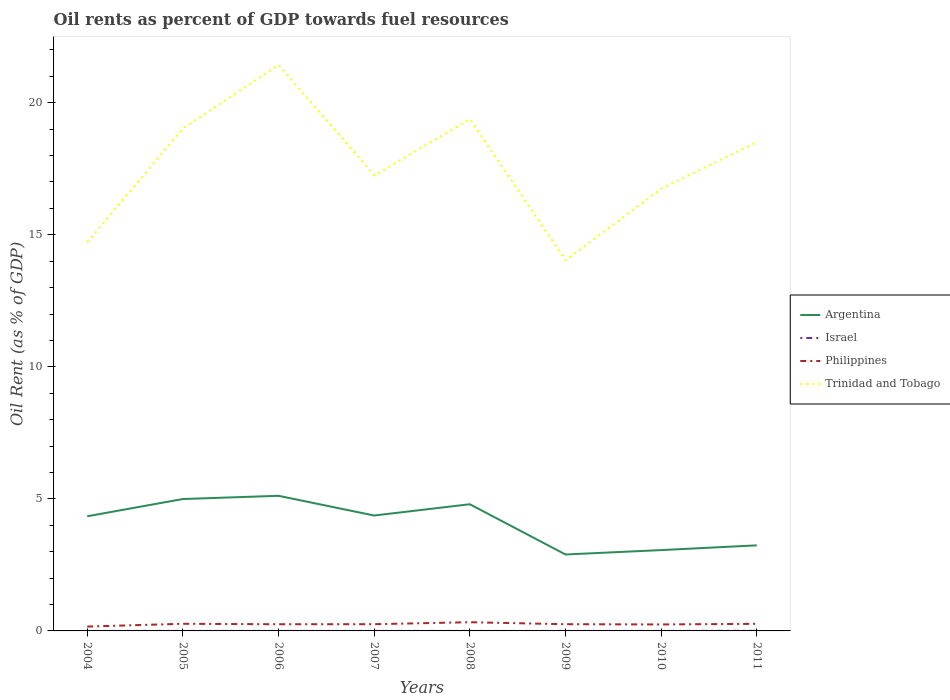How many different coloured lines are there?
Offer a terse response. 4. Across all years, what is the maximum oil rent in Philippines?
Offer a very short reply. 0.16. What is the total oil rent in Argentina in the graph?
Give a very brief answer. 1.31. What is the difference between the highest and the second highest oil rent in Philippines?
Your response must be concise. 0.17. What is the difference between the highest and the lowest oil rent in Israel?
Offer a very short reply. 1. How many lines are there?
Your answer should be very brief. 4. How many years are there in the graph?
Your answer should be compact. 8. What is the difference between two consecutive major ticks on the Y-axis?
Offer a very short reply. 5. Does the graph contain any zero values?
Give a very brief answer. No. What is the title of the graph?
Offer a terse response. Oil rents as percent of GDP towards fuel resources. Does "French Polynesia" appear as one of the legend labels in the graph?
Give a very brief answer. No. What is the label or title of the X-axis?
Your answer should be very brief. Years. What is the label or title of the Y-axis?
Make the answer very short. Oil Rent (as % of GDP). What is the Oil Rent (as % of GDP) of Argentina in 2004?
Your answer should be very brief. 4.34. What is the Oil Rent (as % of GDP) in Israel in 2004?
Keep it short and to the point. 0. What is the Oil Rent (as % of GDP) in Philippines in 2004?
Ensure brevity in your answer.  0.16. What is the Oil Rent (as % of GDP) of Trinidad and Tobago in 2004?
Provide a succinct answer. 14.72. What is the Oil Rent (as % of GDP) of Argentina in 2005?
Make the answer very short. 4.99. What is the Oil Rent (as % of GDP) in Israel in 2005?
Your answer should be very brief. 0. What is the Oil Rent (as % of GDP) of Philippines in 2005?
Ensure brevity in your answer.  0.27. What is the Oil Rent (as % of GDP) of Trinidad and Tobago in 2005?
Make the answer very short. 19.03. What is the Oil Rent (as % of GDP) of Argentina in 2006?
Give a very brief answer. 5.12. What is the Oil Rent (as % of GDP) of Israel in 2006?
Ensure brevity in your answer.  0. What is the Oil Rent (as % of GDP) in Philippines in 2006?
Your response must be concise. 0.25. What is the Oil Rent (as % of GDP) of Trinidad and Tobago in 2006?
Keep it short and to the point. 21.43. What is the Oil Rent (as % of GDP) in Argentina in 2007?
Offer a terse response. 4.37. What is the Oil Rent (as % of GDP) in Israel in 2007?
Your answer should be compact. 0. What is the Oil Rent (as % of GDP) of Philippines in 2007?
Provide a succinct answer. 0.25. What is the Oil Rent (as % of GDP) of Trinidad and Tobago in 2007?
Offer a very short reply. 17.25. What is the Oil Rent (as % of GDP) of Argentina in 2008?
Offer a very short reply. 4.8. What is the Oil Rent (as % of GDP) of Israel in 2008?
Your response must be concise. 0. What is the Oil Rent (as % of GDP) of Philippines in 2008?
Give a very brief answer. 0.33. What is the Oil Rent (as % of GDP) of Trinidad and Tobago in 2008?
Your answer should be very brief. 19.38. What is the Oil Rent (as % of GDP) in Argentina in 2009?
Your answer should be very brief. 2.89. What is the Oil Rent (as % of GDP) of Israel in 2009?
Your answer should be very brief. 0. What is the Oil Rent (as % of GDP) in Philippines in 2009?
Ensure brevity in your answer.  0.25. What is the Oil Rent (as % of GDP) of Trinidad and Tobago in 2009?
Your answer should be very brief. 14.03. What is the Oil Rent (as % of GDP) in Argentina in 2010?
Offer a terse response. 3.06. What is the Oil Rent (as % of GDP) of Israel in 2010?
Your answer should be compact. 0. What is the Oil Rent (as % of GDP) in Philippines in 2010?
Offer a terse response. 0.25. What is the Oil Rent (as % of GDP) in Trinidad and Tobago in 2010?
Provide a short and direct response. 16.75. What is the Oil Rent (as % of GDP) of Argentina in 2011?
Offer a terse response. 3.24. What is the Oil Rent (as % of GDP) of Israel in 2011?
Provide a succinct answer. 0. What is the Oil Rent (as % of GDP) of Philippines in 2011?
Ensure brevity in your answer.  0.27. What is the Oil Rent (as % of GDP) of Trinidad and Tobago in 2011?
Your answer should be compact. 18.51. Across all years, what is the maximum Oil Rent (as % of GDP) of Argentina?
Provide a short and direct response. 5.12. Across all years, what is the maximum Oil Rent (as % of GDP) in Israel?
Your answer should be compact. 0. Across all years, what is the maximum Oil Rent (as % of GDP) in Philippines?
Your response must be concise. 0.33. Across all years, what is the maximum Oil Rent (as % of GDP) in Trinidad and Tobago?
Give a very brief answer. 21.43. Across all years, what is the minimum Oil Rent (as % of GDP) in Argentina?
Make the answer very short. 2.89. Across all years, what is the minimum Oil Rent (as % of GDP) in Israel?
Provide a succinct answer. 0. Across all years, what is the minimum Oil Rent (as % of GDP) in Philippines?
Offer a terse response. 0.16. Across all years, what is the minimum Oil Rent (as % of GDP) in Trinidad and Tobago?
Your answer should be very brief. 14.03. What is the total Oil Rent (as % of GDP) in Argentina in the graph?
Make the answer very short. 32.81. What is the total Oil Rent (as % of GDP) of Israel in the graph?
Offer a very short reply. 0.01. What is the total Oil Rent (as % of GDP) in Philippines in the graph?
Your answer should be very brief. 2.04. What is the total Oil Rent (as % of GDP) in Trinidad and Tobago in the graph?
Your answer should be very brief. 141.1. What is the difference between the Oil Rent (as % of GDP) of Argentina in 2004 and that in 2005?
Your answer should be very brief. -0.65. What is the difference between the Oil Rent (as % of GDP) of Israel in 2004 and that in 2005?
Provide a short and direct response. -0. What is the difference between the Oil Rent (as % of GDP) of Philippines in 2004 and that in 2005?
Offer a terse response. -0.11. What is the difference between the Oil Rent (as % of GDP) in Trinidad and Tobago in 2004 and that in 2005?
Keep it short and to the point. -4.31. What is the difference between the Oil Rent (as % of GDP) in Argentina in 2004 and that in 2006?
Give a very brief answer. -0.78. What is the difference between the Oil Rent (as % of GDP) of Israel in 2004 and that in 2006?
Offer a very short reply. -0. What is the difference between the Oil Rent (as % of GDP) in Philippines in 2004 and that in 2006?
Your response must be concise. -0.09. What is the difference between the Oil Rent (as % of GDP) of Trinidad and Tobago in 2004 and that in 2006?
Ensure brevity in your answer.  -6.71. What is the difference between the Oil Rent (as % of GDP) in Argentina in 2004 and that in 2007?
Make the answer very short. -0.03. What is the difference between the Oil Rent (as % of GDP) of Israel in 2004 and that in 2007?
Your answer should be very brief. -0. What is the difference between the Oil Rent (as % of GDP) of Philippines in 2004 and that in 2007?
Ensure brevity in your answer.  -0.09. What is the difference between the Oil Rent (as % of GDP) of Trinidad and Tobago in 2004 and that in 2007?
Make the answer very short. -2.53. What is the difference between the Oil Rent (as % of GDP) of Argentina in 2004 and that in 2008?
Offer a very short reply. -0.46. What is the difference between the Oil Rent (as % of GDP) of Israel in 2004 and that in 2008?
Keep it short and to the point. -0. What is the difference between the Oil Rent (as % of GDP) in Philippines in 2004 and that in 2008?
Keep it short and to the point. -0.17. What is the difference between the Oil Rent (as % of GDP) in Trinidad and Tobago in 2004 and that in 2008?
Offer a very short reply. -4.66. What is the difference between the Oil Rent (as % of GDP) in Argentina in 2004 and that in 2009?
Offer a terse response. 1.45. What is the difference between the Oil Rent (as % of GDP) of Israel in 2004 and that in 2009?
Ensure brevity in your answer.  -0. What is the difference between the Oil Rent (as % of GDP) of Philippines in 2004 and that in 2009?
Ensure brevity in your answer.  -0.09. What is the difference between the Oil Rent (as % of GDP) of Trinidad and Tobago in 2004 and that in 2009?
Offer a terse response. 0.69. What is the difference between the Oil Rent (as % of GDP) in Argentina in 2004 and that in 2010?
Keep it short and to the point. 1.28. What is the difference between the Oil Rent (as % of GDP) in Israel in 2004 and that in 2010?
Your answer should be very brief. -0. What is the difference between the Oil Rent (as % of GDP) of Philippines in 2004 and that in 2010?
Ensure brevity in your answer.  -0.08. What is the difference between the Oil Rent (as % of GDP) in Trinidad and Tobago in 2004 and that in 2010?
Your response must be concise. -2.03. What is the difference between the Oil Rent (as % of GDP) in Argentina in 2004 and that in 2011?
Offer a terse response. 1.1. What is the difference between the Oil Rent (as % of GDP) of Israel in 2004 and that in 2011?
Make the answer very short. -0. What is the difference between the Oil Rent (as % of GDP) of Philippines in 2004 and that in 2011?
Keep it short and to the point. -0.1. What is the difference between the Oil Rent (as % of GDP) of Trinidad and Tobago in 2004 and that in 2011?
Offer a terse response. -3.79. What is the difference between the Oil Rent (as % of GDP) of Argentina in 2005 and that in 2006?
Your answer should be compact. -0.12. What is the difference between the Oil Rent (as % of GDP) of Israel in 2005 and that in 2006?
Provide a succinct answer. -0. What is the difference between the Oil Rent (as % of GDP) in Philippines in 2005 and that in 2006?
Give a very brief answer. 0.02. What is the difference between the Oil Rent (as % of GDP) in Trinidad and Tobago in 2005 and that in 2006?
Make the answer very short. -2.41. What is the difference between the Oil Rent (as % of GDP) in Argentina in 2005 and that in 2007?
Offer a very short reply. 0.62. What is the difference between the Oil Rent (as % of GDP) of Israel in 2005 and that in 2007?
Offer a terse response. -0. What is the difference between the Oil Rent (as % of GDP) in Philippines in 2005 and that in 2007?
Your answer should be compact. 0.02. What is the difference between the Oil Rent (as % of GDP) of Trinidad and Tobago in 2005 and that in 2007?
Provide a short and direct response. 1.78. What is the difference between the Oil Rent (as % of GDP) in Argentina in 2005 and that in 2008?
Your answer should be compact. 0.2. What is the difference between the Oil Rent (as % of GDP) of Israel in 2005 and that in 2008?
Keep it short and to the point. -0. What is the difference between the Oil Rent (as % of GDP) of Philippines in 2005 and that in 2008?
Keep it short and to the point. -0.06. What is the difference between the Oil Rent (as % of GDP) in Trinidad and Tobago in 2005 and that in 2008?
Ensure brevity in your answer.  -0.35. What is the difference between the Oil Rent (as % of GDP) in Argentina in 2005 and that in 2009?
Make the answer very short. 2.1. What is the difference between the Oil Rent (as % of GDP) in Israel in 2005 and that in 2009?
Keep it short and to the point. 0. What is the difference between the Oil Rent (as % of GDP) of Philippines in 2005 and that in 2009?
Offer a very short reply. 0.02. What is the difference between the Oil Rent (as % of GDP) of Trinidad and Tobago in 2005 and that in 2009?
Offer a very short reply. 4.99. What is the difference between the Oil Rent (as % of GDP) in Argentina in 2005 and that in 2010?
Offer a very short reply. 1.93. What is the difference between the Oil Rent (as % of GDP) in Philippines in 2005 and that in 2010?
Offer a terse response. 0.02. What is the difference between the Oil Rent (as % of GDP) of Trinidad and Tobago in 2005 and that in 2010?
Provide a short and direct response. 2.28. What is the difference between the Oil Rent (as % of GDP) in Argentina in 2005 and that in 2011?
Offer a terse response. 1.75. What is the difference between the Oil Rent (as % of GDP) of Israel in 2005 and that in 2011?
Your answer should be very brief. -0. What is the difference between the Oil Rent (as % of GDP) in Philippines in 2005 and that in 2011?
Provide a short and direct response. 0. What is the difference between the Oil Rent (as % of GDP) of Trinidad and Tobago in 2005 and that in 2011?
Give a very brief answer. 0.52. What is the difference between the Oil Rent (as % of GDP) of Argentina in 2006 and that in 2007?
Give a very brief answer. 0.75. What is the difference between the Oil Rent (as % of GDP) of Philippines in 2006 and that in 2007?
Your answer should be very brief. -0. What is the difference between the Oil Rent (as % of GDP) of Trinidad and Tobago in 2006 and that in 2007?
Keep it short and to the point. 4.19. What is the difference between the Oil Rent (as % of GDP) in Argentina in 2006 and that in 2008?
Give a very brief answer. 0.32. What is the difference between the Oil Rent (as % of GDP) of Israel in 2006 and that in 2008?
Make the answer very short. -0. What is the difference between the Oil Rent (as % of GDP) of Philippines in 2006 and that in 2008?
Your answer should be compact. -0.08. What is the difference between the Oil Rent (as % of GDP) of Trinidad and Tobago in 2006 and that in 2008?
Your answer should be compact. 2.06. What is the difference between the Oil Rent (as % of GDP) of Argentina in 2006 and that in 2009?
Provide a short and direct response. 2.22. What is the difference between the Oil Rent (as % of GDP) of Philippines in 2006 and that in 2009?
Your answer should be compact. -0. What is the difference between the Oil Rent (as % of GDP) in Trinidad and Tobago in 2006 and that in 2009?
Offer a very short reply. 7.4. What is the difference between the Oil Rent (as % of GDP) of Argentina in 2006 and that in 2010?
Your answer should be very brief. 2.06. What is the difference between the Oil Rent (as % of GDP) of Philippines in 2006 and that in 2010?
Make the answer very short. 0.01. What is the difference between the Oil Rent (as % of GDP) in Trinidad and Tobago in 2006 and that in 2010?
Provide a succinct answer. 4.69. What is the difference between the Oil Rent (as % of GDP) of Argentina in 2006 and that in 2011?
Your response must be concise. 1.88. What is the difference between the Oil Rent (as % of GDP) in Israel in 2006 and that in 2011?
Your response must be concise. -0. What is the difference between the Oil Rent (as % of GDP) of Philippines in 2006 and that in 2011?
Make the answer very short. -0.02. What is the difference between the Oil Rent (as % of GDP) in Trinidad and Tobago in 2006 and that in 2011?
Your answer should be compact. 2.92. What is the difference between the Oil Rent (as % of GDP) of Argentina in 2007 and that in 2008?
Ensure brevity in your answer.  -0.43. What is the difference between the Oil Rent (as % of GDP) of Israel in 2007 and that in 2008?
Provide a succinct answer. -0. What is the difference between the Oil Rent (as % of GDP) of Philippines in 2007 and that in 2008?
Give a very brief answer. -0.07. What is the difference between the Oil Rent (as % of GDP) of Trinidad and Tobago in 2007 and that in 2008?
Offer a very short reply. -2.13. What is the difference between the Oil Rent (as % of GDP) in Argentina in 2007 and that in 2009?
Offer a terse response. 1.48. What is the difference between the Oil Rent (as % of GDP) in Trinidad and Tobago in 2007 and that in 2009?
Offer a terse response. 3.21. What is the difference between the Oil Rent (as % of GDP) in Argentina in 2007 and that in 2010?
Your response must be concise. 1.31. What is the difference between the Oil Rent (as % of GDP) of Israel in 2007 and that in 2010?
Offer a terse response. 0. What is the difference between the Oil Rent (as % of GDP) in Philippines in 2007 and that in 2010?
Your answer should be compact. 0.01. What is the difference between the Oil Rent (as % of GDP) in Trinidad and Tobago in 2007 and that in 2010?
Your response must be concise. 0.5. What is the difference between the Oil Rent (as % of GDP) of Argentina in 2007 and that in 2011?
Your response must be concise. 1.13. What is the difference between the Oil Rent (as % of GDP) of Israel in 2007 and that in 2011?
Offer a terse response. -0. What is the difference between the Oil Rent (as % of GDP) of Philippines in 2007 and that in 2011?
Provide a short and direct response. -0.01. What is the difference between the Oil Rent (as % of GDP) in Trinidad and Tobago in 2007 and that in 2011?
Give a very brief answer. -1.26. What is the difference between the Oil Rent (as % of GDP) of Argentina in 2008 and that in 2009?
Offer a very short reply. 1.9. What is the difference between the Oil Rent (as % of GDP) of Israel in 2008 and that in 2009?
Ensure brevity in your answer.  0. What is the difference between the Oil Rent (as % of GDP) in Philippines in 2008 and that in 2009?
Keep it short and to the point. 0.08. What is the difference between the Oil Rent (as % of GDP) of Trinidad and Tobago in 2008 and that in 2009?
Provide a succinct answer. 5.34. What is the difference between the Oil Rent (as % of GDP) of Argentina in 2008 and that in 2010?
Your answer should be compact. 1.74. What is the difference between the Oil Rent (as % of GDP) of Philippines in 2008 and that in 2010?
Provide a short and direct response. 0.08. What is the difference between the Oil Rent (as % of GDP) of Trinidad and Tobago in 2008 and that in 2010?
Make the answer very short. 2.63. What is the difference between the Oil Rent (as % of GDP) of Argentina in 2008 and that in 2011?
Provide a short and direct response. 1.56. What is the difference between the Oil Rent (as % of GDP) in Israel in 2008 and that in 2011?
Keep it short and to the point. -0. What is the difference between the Oil Rent (as % of GDP) of Philippines in 2008 and that in 2011?
Provide a succinct answer. 0.06. What is the difference between the Oil Rent (as % of GDP) of Trinidad and Tobago in 2008 and that in 2011?
Provide a succinct answer. 0.87. What is the difference between the Oil Rent (as % of GDP) of Argentina in 2009 and that in 2010?
Provide a short and direct response. -0.17. What is the difference between the Oil Rent (as % of GDP) of Israel in 2009 and that in 2010?
Provide a succinct answer. -0. What is the difference between the Oil Rent (as % of GDP) in Philippines in 2009 and that in 2010?
Give a very brief answer. 0.01. What is the difference between the Oil Rent (as % of GDP) of Trinidad and Tobago in 2009 and that in 2010?
Provide a short and direct response. -2.71. What is the difference between the Oil Rent (as % of GDP) in Argentina in 2009 and that in 2011?
Provide a succinct answer. -0.35. What is the difference between the Oil Rent (as % of GDP) in Israel in 2009 and that in 2011?
Provide a succinct answer. -0. What is the difference between the Oil Rent (as % of GDP) in Philippines in 2009 and that in 2011?
Offer a terse response. -0.01. What is the difference between the Oil Rent (as % of GDP) in Trinidad and Tobago in 2009 and that in 2011?
Provide a succinct answer. -4.48. What is the difference between the Oil Rent (as % of GDP) in Argentina in 2010 and that in 2011?
Give a very brief answer. -0.18. What is the difference between the Oil Rent (as % of GDP) of Israel in 2010 and that in 2011?
Ensure brevity in your answer.  -0. What is the difference between the Oil Rent (as % of GDP) in Philippines in 2010 and that in 2011?
Provide a short and direct response. -0.02. What is the difference between the Oil Rent (as % of GDP) of Trinidad and Tobago in 2010 and that in 2011?
Your answer should be very brief. -1.76. What is the difference between the Oil Rent (as % of GDP) of Argentina in 2004 and the Oil Rent (as % of GDP) of Israel in 2005?
Ensure brevity in your answer.  4.34. What is the difference between the Oil Rent (as % of GDP) of Argentina in 2004 and the Oil Rent (as % of GDP) of Philippines in 2005?
Your answer should be very brief. 4.07. What is the difference between the Oil Rent (as % of GDP) of Argentina in 2004 and the Oil Rent (as % of GDP) of Trinidad and Tobago in 2005?
Your answer should be compact. -14.69. What is the difference between the Oil Rent (as % of GDP) of Israel in 2004 and the Oil Rent (as % of GDP) of Philippines in 2005?
Ensure brevity in your answer.  -0.27. What is the difference between the Oil Rent (as % of GDP) in Israel in 2004 and the Oil Rent (as % of GDP) in Trinidad and Tobago in 2005?
Offer a very short reply. -19.03. What is the difference between the Oil Rent (as % of GDP) of Philippines in 2004 and the Oil Rent (as % of GDP) of Trinidad and Tobago in 2005?
Give a very brief answer. -18.86. What is the difference between the Oil Rent (as % of GDP) in Argentina in 2004 and the Oil Rent (as % of GDP) in Israel in 2006?
Keep it short and to the point. 4.34. What is the difference between the Oil Rent (as % of GDP) of Argentina in 2004 and the Oil Rent (as % of GDP) of Philippines in 2006?
Ensure brevity in your answer.  4.09. What is the difference between the Oil Rent (as % of GDP) in Argentina in 2004 and the Oil Rent (as % of GDP) in Trinidad and Tobago in 2006?
Offer a terse response. -17.09. What is the difference between the Oil Rent (as % of GDP) in Israel in 2004 and the Oil Rent (as % of GDP) in Philippines in 2006?
Your response must be concise. -0.25. What is the difference between the Oil Rent (as % of GDP) of Israel in 2004 and the Oil Rent (as % of GDP) of Trinidad and Tobago in 2006?
Ensure brevity in your answer.  -21.43. What is the difference between the Oil Rent (as % of GDP) in Philippines in 2004 and the Oil Rent (as % of GDP) in Trinidad and Tobago in 2006?
Offer a very short reply. -21.27. What is the difference between the Oil Rent (as % of GDP) of Argentina in 2004 and the Oil Rent (as % of GDP) of Israel in 2007?
Provide a succinct answer. 4.34. What is the difference between the Oil Rent (as % of GDP) in Argentina in 2004 and the Oil Rent (as % of GDP) in Philippines in 2007?
Provide a short and direct response. 4.09. What is the difference between the Oil Rent (as % of GDP) of Argentina in 2004 and the Oil Rent (as % of GDP) of Trinidad and Tobago in 2007?
Your answer should be compact. -12.91. What is the difference between the Oil Rent (as % of GDP) of Israel in 2004 and the Oil Rent (as % of GDP) of Philippines in 2007?
Make the answer very short. -0.25. What is the difference between the Oil Rent (as % of GDP) in Israel in 2004 and the Oil Rent (as % of GDP) in Trinidad and Tobago in 2007?
Provide a short and direct response. -17.25. What is the difference between the Oil Rent (as % of GDP) in Philippines in 2004 and the Oil Rent (as % of GDP) in Trinidad and Tobago in 2007?
Your response must be concise. -17.08. What is the difference between the Oil Rent (as % of GDP) in Argentina in 2004 and the Oil Rent (as % of GDP) in Israel in 2008?
Provide a short and direct response. 4.34. What is the difference between the Oil Rent (as % of GDP) of Argentina in 2004 and the Oil Rent (as % of GDP) of Philippines in 2008?
Give a very brief answer. 4.01. What is the difference between the Oil Rent (as % of GDP) in Argentina in 2004 and the Oil Rent (as % of GDP) in Trinidad and Tobago in 2008?
Your response must be concise. -15.04. What is the difference between the Oil Rent (as % of GDP) in Israel in 2004 and the Oil Rent (as % of GDP) in Philippines in 2008?
Offer a very short reply. -0.33. What is the difference between the Oil Rent (as % of GDP) of Israel in 2004 and the Oil Rent (as % of GDP) of Trinidad and Tobago in 2008?
Provide a short and direct response. -19.38. What is the difference between the Oil Rent (as % of GDP) in Philippines in 2004 and the Oil Rent (as % of GDP) in Trinidad and Tobago in 2008?
Keep it short and to the point. -19.21. What is the difference between the Oil Rent (as % of GDP) of Argentina in 2004 and the Oil Rent (as % of GDP) of Israel in 2009?
Offer a terse response. 4.34. What is the difference between the Oil Rent (as % of GDP) of Argentina in 2004 and the Oil Rent (as % of GDP) of Philippines in 2009?
Make the answer very short. 4.09. What is the difference between the Oil Rent (as % of GDP) of Argentina in 2004 and the Oil Rent (as % of GDP) of Trinidad and Tobago in 2009?
Offer a terse response. -9.69. What is the difference between the Oil Rent (as % of GDP) of Israel in 2004 and the Oil Rent (as % of GDP) of Philippines in 2009?
Ensure brevity in your answer.  -0.25. What is the difference between the Oil Rent (as % of GDP) in Israel in 2004 and the Oil Rent (as % of GDP) in Trinidad and Tobago in 2009?
Make the answer very short. -14.03. What is the difference between the Oil Rent (as % of GDP) in Philippines in 2004 and the Oil Rent (as % of GDP) in Trinidad and Tobago in 2009?
Make the answer very short. -13.87. What is the difference between the Oil Rent (as % of GDP) of Argentina in 2004 and the Oil Rent (as % of GDP) of Israel in 2010?
Provide a short and direct response. 4.34. What is the difference between the Oil Rent (as % of GDP) in Argentina in 2004 and the Oil Rent (as % of GDP) in Philippines in 2010?
Offer a very short reply. 4.1. What is the difference between the Oil Rent (as % of GDP) in Argentina in 2004 and the Oil Rent (as % of GDP) in Trinidad and Tobago in 2010?
Your answer should be compact. -12.41. What is the difference between the Oil Rent (as % of GDP) in Israel in 2004 and the Oil Rent (as % of GDP) in Philippines in 2010?
Provide a short and direct response. -0.24. What is the difference between the Oil Rent (as % of GDP) of Israel in 2004 and the Oil Rent (as % of GDP) of Trinidad and Tobago in 2010?
Your answer should be very brief. -16.75. What is the difference between the Oil Rent (as % of GDP) of Philippines in 2004 and the Oil Rent (as % of GDP) of Trinidad and Tobago in 2010?
Make the answer very short. -16.58. What is the difference between the Oil Rent (as % of GDP) of Argentina in 2004 and the Oil Rent (as % of GDP) of Israel in 2011?
Ensure brevity in your answer.  4.34. What is the difference between the Oil Rent (as % of GDP) of Argentina in 2004 and the Oil Rent (as % of GDP) of Philippines in 2011?
Keep it short and to the point. 4.07. What is the difference between the Oil Rent (as % of GDP) in Argentina in 2004 and the Oil Rent (as % of GDP) in Trinidad and Tobago in 2011?
Offer a terse response. -14.17. What is the difference between the Oil Rent (as % of GDP) in Israel in 2004 and the Oil Rent (as % of GDP) in Philippines in 2011?
Ensure brevity in your answer.  -0.27. What is the difference between the Oil Rent (as % of GDP) of Israel in 2004 and the Oil Rent (as % of GDP) of Trinidad and Tobago in 2011?
Offer a very short reply. -18.51. What is the difference between the Oil Rent (as % of GDP) of Philippines in 2004 and the Oil Rent (as % of GDP) of Trinidad and Tobago in 2011?
Ensure brevity in your answer.  -18.34. What is the difference between the Oil Rent (as % of GDP) in Argentina in 2005 and the Oil Rent (as % of GDP) in Israel in 2006?
Your answer should be compact. 4.99. What is the difference between the Oil Rent (as % of GDP) in Argentina in 2005 and the Oil Rent (as % of GDP) in Philippines in 2006?
Provide a short and direct response. 4.74. What is the difference between the Oil Rent (as % of GDP) of Argentina in 2005 and the Oil Rent (as % of GDP) of Trinidad and Tobago in 2006?
Keep it short and to the point. -16.44. What is the difference between the Oil Rent (as % of GDP) in Israel in 2005 and the Oil Rent (as % of GDP) in Philippines in 2006?
Your response must be concise. -0.25. What is the difference between the Oil Rent (as % of GDP) in Israel in 2005 and the Oil Rent (as % of GDP) in Trinidad and Tobago in 2006?
Your answer should be very brief. -21.43. What is the difference between the Oil Rent (as % of GDP) of Philippines in 2005 and the Oil Rent (as % of GDP) of Trinidad and Tobago in 2006?
Your answer should be very brief. -21.16. What is the difference between the Oil Rent (as % of GDP) in Argentina in 2005 and the Oil Rent (as % of GDP) in Israel in 2007?
Your response must be concise. 4.99. What is the difference between the Oil Rent (as % of GDP) of Argentina in 2005 and the Oil Rent (as % of GDP) of Philippines in 2007?
Give a very brief answer. 4.74. What is the difference between the Oil Rent (as % of GDP) in Argentina in 2005 and the Oil Rent (as % of GDP) in Trinidad and Tobago in 2007?
Make the answer very short. -12.25. What is the difference between the Oil Rent (as % of GDP) of Israel in 2005 and the Oil Rent (as % of GDP) of Philippines in 2007?
Make the answer very short. -0.25. What is the difference between the Oil Rent (as % of GDP) of Israel in 2005 and the Oil Rent (as % of GDP) of Trinidad and Tobago in 2007?
Keep it short and to the point. -17.25. What is the difference between the Oil Rent (as % of GDP) in Philippines in 2005 and the Oil Rent (as % of GDP) in Trinidad and Tobago in 2007?
Ensure brevity in your answer.  -16.98. What is the difference between the Oil Rent (as % of GDP) in Argentina in 2005 and the Oil Rent (as % of GDP) in Israel in 2008?
Your answer should be compact. 4.99. What is the difference between the Oil Rent (as % of GDP) of Argentina in 2005 and the Oil Rent (as % of GDP) of Philippines in 2008?
Give a very brief answer. 4.66. What is the difference between the Oil Rent (as % of GDP) of Argentina in 2005 and the Oil Rent (as % of GDP) of Trinidad and Tobago in 2008?
Ensure brevity in your answer.  -14.38. What is the difference between the Oil Rent (as % of GDP) of Israel in 2005 and the Oil Rent (as % of GDP) of Philippines in 2008?
Offer a terse response. -0.33. What is the difference between the Oil Rent (as % of GDP) of Israel in 2005 and the Oil Rent (as % of GDP) of Trinidad and Tobago in 2008?
Your answer should be very brief. -19.38. What is the difference between the Oil Rent (as % of GDP) in Philippines in 2005 and the Oil Rent (as % of GDP) in Trinidad and Tobago in 2008?
Your answer should be compact. -19.11. What is the difference between the Oil Rent (as % of GDP) of Argentina in 2005 and the Oil Rent (as % of GDP) of Israel in 2009?
Provide a succinct answer. 4.99. What is the difference between the Oil Rent (as % of GDP) in Argentina in 2005 and the Oil Rent (as % of GDP) in Philippines in 2009?
Your answer should be compact. 4.74. What is the difference between the Oil Rent (as % of GDP) of Argentina in 2005 and the Oil Rent (as % of GDP) of Trinidad and Tobago in 2009?
Offer a terse response. -9.04. What is the difference between the Oil Rent (as % of GDP) of Israel in 2005 and the Oil Rent (as % of GDP) of Philippines in 2009?
Give a very brief answer. -0.25. What is the difference between the Oil Rent (as % of GDP) of Israel in 2005 and the Oil Rent (as % of GDP) of Trinidad and Tobago in 2009?
Give a very brief answer. -14.03. What is the difference between the Oil Rent (as % of GDP) of Philippines in 2005 and the Oil Rent (as % of GDP) of Trinidad and Tobago in 2009?
Provide a succinct answer. -13.76. What is the difference between the Oil Rent (as % of GDP) of Argentina in 2005 and the Oil Rent (as % of GDP) of Israel in 2010?
Your answer should be very brief. 4.99. What is the difference between the Oil Rent (as % of GDP) in Argentina in 2005 and the Oil Rent (as % of GDP) in Philippines in 2010?
Ensure brevity in your answer.  4.75. What is the difference between the Oil Rent (as % of GDP) in Argentina in 2005 and the Oil Rent (as % of GDP) in Trinidad and Tobago in 2010?
Make the answer very short. -11.75. What is the difference between the Oil Rent (as % of GDP) in Israel in 2005 and the Oil Rent (as % of GDP) in Philippines in 2010?
Make the answer very short. -0.24. What is the difference between the Oil Rent (as % of GDP) of Israel in 2005 and the Oil Rent (as % of GDP) of Trinidad and Tobago in 2010?
Offer a terse response. -16.75. What is the difference between the Oil Rent (as % of GDP) in Philippines in 2005 and the Oil Rent (as % of GDP) in Trinidad and Tobago in 2010?
Provide a short and direct response. -16.48. What is the difference between the Oil Rent (as % of GDP) of Argentina in 2005 and the Oil Rent (as % of GDP) of Israel in 2011?
Ensure brevity in your answer.  4.99. What is the difference between the Oil Rent (as % of GDP) of Argentina in 2005 and the Oil Rent (as % of GDP) of Philippines in 2011?
Keep it short and to the point. 4.73. What is the difference between the Oil Rent (as % of GDP) in Argentina in 2005 and the Oil Rent (as % of GDP) in Trinidad and Tobago in 2011?
Give a very brief answer. -13.52. What is the difference between the Oil Rent (as % of GDP) in Israel in 2005 and the Oil Rent (as % of GDP) in Philippines in 2011?
Offer a very short reply. -0.27. What is the difference between the Oil Rent (as % of GDP) of Israel in 2005 and the Oil Rent (as % of GDP) of Trinidad and Tobago in 2011?
Keep it short and to the point. -18.51. What is the difference between the Oil Rent (as % of GDP) in Philippines in 2005 and the Oil Rent (as % of GDP) in Trinidad and Tobago in 2011?
Provide a succinct answer. -18.24. What is the difference between the Oil Rent (as % of GDP) in Argentina in 2006 and the Oil Rent (as % of GDP) in Israel in 2007?
Make the answer very short. 5.12. What is the difference between the Oil Rent (as % of GDP) of Argentina in 2006 and the Oil Rent (as % of GDP) of Philippines in 2007?
Provide a short and direct response. 4.86. What is the difference between the Oil Rent (as % of GDP) of Argentina in 2006 and the Oil Rent (as % of GDP) of Trinidad and Tobago in 2007?
Provide a succinct answer. -12.13. What is the difference between the Oil Rent (as % of GDP) in Israel in 2006 and the Oil Rent (as % of GDP) in Philippines in 2007?
Make the answer very short. -0.25. What is the difference between the Oil Rent (as % of GDP) of Israel in 2006 and the Oil Rent (as % of GDP) of Trinidad and Tobago in 2007?
Make the answer very short. -17.25. What is the difference between the Oil Rent (as % of GDP) in Philippines in 2006 and the Oil Rent (as % of GDP) in Trinidad and Tobago in 2007?
Provide a succinct answer. -17. What is the difference between the Oil Rent (as % of GDP) in Argentina in 2006 and the Oil Rent (as % of GDP) in Israel in 2008?
Your answer should be compact. 5.12. What is the difference between the Oil Rent (as % of GDP) of Argentina in 2006 and the Oil Rent (as % of GDP) of Philippines in 2008?
Offer a terse response. 4.79. What is the difference between the Oil Rent (as % of GDP) of Argentina in 2006 and the Oil Rent (as % of GDP) of Trinidad and Tobago in 2008?
Make the answer very short. -14.26. What is the difference between the Oil Rent (as % of GDP) in Israel in 2006 and the Oil Rent (as % of GDP) in Philippines in 2008?
Give a very brief answer. -0.33. What is the difference between the Oil Rent (as % of GDP) in Israel in 2006 and the Oil Rent (as % of GDP) in Trinidad and Tobago in 2008?
Provide a succinct answer. -19.38. What is the difference between the Oil Rent (as % of GDP) of Philippines in 2006 and the Oil Rent (as % of GDP) of Trinidad and Tobago in 2008?
Make the answer very short. -19.12. What is the difference between the Oil Rent (as % of GDP) in Argentina in 2006 and the Oil Rent (as % of GDP) in Israel in 2009?
Ensure brevity in your answer.  5.12. What is the difference between the Oil Rent (as % of GDP) in Argentina in 2006 and the Oil Rent (as % of GDP) in Philippines in 2009?
Your answer should be very brief. 4.86. What is the difference between the Oil Rent (as % of GDP) in Argentina in 2006 and the Oil Rent (as % of GDP) in Trinidad and Tobago in 2009?
Offer a very short reply. -8.92. What is the difference between the Oil Rent (as % of GDP) of Israel in 2006 and the Oil Rent (as % of GDP) of Philippines in 2009?
Ensure brevity in your answer.  -0.25. What is the difference between the Oil Rent (as % of GDP) in Israel in 2006 and the Oil Rent (as % of GDP) in Trinidad and Tobago in 2009?
Give a very brief answer. -14.03. What is the difference between the Oil Rent (as % of GDP) of Philippines in 2006 and the Oil Rent (as % of GDP) of Trinidad and Tobago in 2009?
Your answer should be compact. -13.78. What is the difference between the Oil Rent (as % of GDP) of Argentina in 2006 and the Oil Rent (as % of GDP) of Israel in 2010?
Provide a succinct answer. 5.12. What is the difference between the Oil Rent (as % of GDP) in Argentina in 2006 and the Oil Rent (as % of GDP) in Philippines in 2010?
Offer a terse response. 4.87. What is the difference between the Oil Rent (as % of GDP) of Argentina in 2006 and the Oil Rent (as % of GDP) of Trinidad and Tobago in 2010?
Ensure brevity in your answer.  -11.63. What is the difference between the Oil Rent (as % of GDP) of Israel in 2006 and the Oil Rent (as % of GDP) of Philippines in 2010?
Provide a succinct answer. -0.24. What is the difference between the Oil Rent (as % of GDP) of Israel in 2006 and the Oil Rent (as % of GDP) of Trinidad and Tobago in 2010?
Ensure brevity in your answer.  -16.75. What is the difference between the Oil Rent (as % of GDP) of Philippines in 2006 and the Oil Rent (as % of GDP) of Trinidad and Tobago in 2010?
Your answer should be compact. -16.5. What is the difference between the Oil Rent (as % of GDP) of Argentina in 2006 and the Oil Rent (as % of GDP) of Israel in 2011?
Offer a very short reply. 5.11. What is the difference between the Oil Rent (as % of GDP) of Argentina in 2006 and the Oil Rent (as % of GDP) of Philippines in 2011?
Offer a terse response. 4.85. What is the difference between the Oil Rent (as % of GDP) of Argentina in 2006 and the Oil Rent (as % of GDP) of Trinidad and Tobago in 2011?
Offer a terse response. -13.39. What is the difference between the Oil Rent (as % of GDP) of Israel in 2006 and the Oil Rent (as % of GDP) of Philippines in 2011?
Keep it short and to the point. -0.27. What is the difference between the Oil Rent (as % of GDP) of Israel in 2006 and the Oil Rent (as % of GDP) of Trinidad and Tobago in 2011?
Provide a succinct answer. -18.51. What is the difference between the Oil Rent (as % of GDP) in Philippines in 2006 and the Oil Rent (as % of GDP) in Trinidad and Tobago in 2011?
Keep it short and to the point. -18.26. What is the difference between the Oil Rent (as % of GDP) of Argentina in 2007 and the Oil Rent (as % of GDP) of Israel in 2008?
Make the answer very short. 4.37. What is the difference between the Oil Rent (as % of GDP) of Argentina in 2007 and the Oil Rent (as % of GDP) of Philippines in 2008?
Give a very brief answer. 4.04. What is the difference between the Oil Rent (as % of GDP) in Argentina in 2007 and the Oil Rent (as % of GDP) in Trinidad and Tobago in 2008?
Your answer should be compact. -15.01. What is the difference between the Oil Rent (as % of GDP) of Israel in 2007 and the Oil Rent (as % of GDP) of Philippines in 2008?
Keep it short and to the point. -0.33. What is the difference between the Oil Rent (as % of GDP) in Israel in 2007 and the Oil Rent (as % of GDP) in Trinidad and Tobago in 2008?
Ensure brevity in your answer.  -19.38. What is the difference between the Oil Rent (as % of GDP) of Philippines in 2007 and the Oil Rent (as % of GDP) of Trinidad and Tobago in 2008?
Your response must be concise. -19.12. What is the difference between the Oil Rent (as % of GDP) in Argentina in 2007 and the Oil Rent (as % of GDP) in Israel in 2009?
Keep it short and to the point. 4.37. What is the difference between the Oil Rent (as % of GDP) of Argentina in 2007 and the Oil Rent (as % of GDP) of Philippines in 2009?
Offer a terse response. 4.12. What is the difference between the Oil Rent (as % of GDP) in Argentina in 2007 and the Oil Rent (as % of GDP) in Trinidad and Tobago in 2009?
Provide a succinct answer. -9.66. What is the difference between the Oil Rent (as % of GDP) in Israel in 2007 and the Oil Rent (as % of GDP) in Philippines in 2009?
Offer a terse response. -0.25. What is the difference between the Oil Rent (as % of GDP) in Israel in 2007 and the Oil Rent (as % of GDP) in Trinidad and Tobago in 2009?
Offer a terse response. -14.03. What is the difference between the Oil Rent (as % of GDP) of Philippines in 2007 and the Oil Rent (as % of GDP) of Trinidad and Tobago in 2009?
Offer a terse response. -13.78. What is the difference between the Oil Rent (as % of GDP) of Argentina in 2007 and the Oil Rent (as % of GDP) of Israel in 2010?
Offer a very short reply. 4.37. What is the difference between the Oil Rent (as % of GDP) in Argentina in 2007 and the Oil Rent (as % of GDP) in Philippines in 2010?
Your answer should be compact. 4.12. What is the difference between the Oil Rent (as % of GDP) of Argentina in 2007 and the Oil Rent (as % of GDP) of Trinidad and Tobago in 2010?
Provide a succinct answer. -12.38. What is the difference between the Oil Rent (as % of GDP) of Israel in 2007 and the Oil Rent (as % of GDP) of Philippines in 2010?
Give a very brief answer. -0.24. What is the difference between the Oil Rent (as % of GDP) of Israel in 2007 and the Oil Rent (as % of GDP) of Trinidad and Tobago in 2010?
Your response must be concise. -16.75. What is the difference between the Oil Rent (as % of GDP) in Philippines in 2007 and the Oil Rent (as % of GDP) in Trinidad and Tobago in 2010?
Provide a succinct answer. -16.49. What is the difference between the Oil Rent (as % of GDP) of Argentina in 2007 and the Oil Rent (as % of GDP) of Israel in 2011?
Keep it short and to the point. 4.37. What is the difference between the Oil Rent (as % of GDP) in Argentina in 2007 and the Oil Rent (as % of GDP) in Philippines in 2011?
Provide a short and direct response. 4.1. What is the difference between the Oil Rent (as % of GDP) of Argentina in 2007 and the Oil Rent (as % of GDP) of Trinidad and Tobago in 2011?
Provide a short and direct response. -14.14. What is the difference between the Oil Rent (as % of GDP) in Israel in 2007 and the Oil Rent (as % of GDP) in Philippines in 2011?
Ensure brevity in your answer.  -0.27. What is the difference between the Oil Rent (as % of GDP) of Israel in 2007 and the Oil Rent (as % of GDP) of Trinidad and Tobago in 2011?
Offer a very short reply. -18.51. What is the difference between the Oil Rent (as % of GDP) in Philippines in 2007 and the Oil Rent (as % of GDP) in Trinidad and Tobago in 2011?
Your response must be concise. -18.25. What is the difference between the Oil Rent (as % of GDP) of Argentina in 2008 and the Oil Rent (as % of GDP) of Israel in 2009?
Give a very brief answer. 4.8. What is the difference between the Oil Rent (as % of GDP) in Argentina in 2008 and the Oil Rent (as % of GDP) in Philippines in 2009?
Ensure brevity in your answer.  4.54. What is the difference between the Oil Rent (as % of GDP) in Argentina in 2008 and the Oil Rent (as % of GDP) in Trinidad and Tobago in 2009?
Make the answer very short. -9.24. What is the difference between the Oil Rent (as % of GDP) in Israel in 2008 and the Oil Rent (as % of GDP) in Philippines in 2009?
Give a very brief answer. -0.25. What is the difference between the Oil Rent (as % of GDP) in Israel in 2008 and the Oil Rent (as % of GDP) in Trinidad and Tobago in 2009?
Provide a short and direct response. -14.03. What is the difference between the Oil Rent (as % of GDP) in Philippines in 2008 and the Oil Rent (as % of GDP) in Trinidad and Tobago in 2009?
Offer a very short reply. -13.7. What is the difference between the Oil Rent (as % of GDP) in Argentina in 2008 and the Oil Rent (as % of GDP) in Israel in 2010?
Provide a short and direct response. 4.8. What is the difference between the Oil Rent (as % of GDP) of Argentina in 2008 and the Oil Rent (as % of GDP) of Philippines in 2010?
Provide a succinct answer. 4.55. What is the difference between the Oil Rent (as % of GDP) of Argentina in 2008 and the Oil Rent (as % of GDP) of Trinidad and Tobago in 2010?
Offer a very short reply. -11.95. What is the difference between the Oil Rent (as % of GDP) of Israel in 2008 and the Oil Rent (as % of GDP) of Philippines in 2010?
Keep it short and to the point. -0.24. What is the difference between the Oil Rent (as % of GDP) in Israel in 2008 and the Oil Rent (as % of GDP) in Trinidad and Tobago in 2010?
Provide a succinct answer. -16.75. What is the difference between the Oil Rent (as % of GDP) of Philippines in 2008 and the Oil Rent (as % of GDP) of Trinidad and Tobago in 2010?
Keep it short and to the point. -16.42. What is the difference between the Oil Rent (as % of GDP) of Argentina in 2008 and the Oil Rent (as % of GDP) of Israel in 2011?
Ensure brevity in your answer.  4.79. What is the difference between the Oil Rent (as % of GDP) in Argentina in 2008 and the Oil Rent (as % of GDP) in Philippines in 2011?
Offer a terse response. 4.53. What is the difference between the Oil Rent (as % of GDP) in Argentina in 2008 and the Oil Rent (as % of GDP) in Trinidad and Tobago in 2011?
Provide a short and direct response. -13.71. What is the difference between the Oil Rent (as % of GDP) in Israel in 2008 and the Oil Rent (as % of GDP) in Philippines in 2011?
Make the answer very short. -0.27. What is the difference between the Oil Rent (as % of GDP) of Israel in 2008 and the Oil Rent (as % of GDP) of Trinidad and Tobago in 2011?
Provide a succinct answer. -18.51. What is the difference between the Oil Rent (as % of GDP) in Philippines in 2008 and the Oil Rent (as % of GDP) in Trinidad and Tobago in 2011?
Offer a terse response. -18.18. What is the difference between the Oil Rent (as % of GDP) in Argentina in 2009 and the Oil Rent (as % of GDP) in Israel in 2010?
Provide a succinct answer. 2.89. What is the difference between the Oil Rent (as % of GDP) of Argentina in 2009 and the Oil Rent (as % of GDP) of Philippines in 2010?
Offer a very short reply. 2.65. What is the difference between the Oil Rent (as % of GDP) of Argentina in 2009 and the Oil Rent (as % of GDP) of Trinidad and Tobago in 2010?
Your answer should be very brief. -13.85. What is the difference between the Oil Rent (as % of GDP) in Israel in 2009 and the Oil Rent (as % of GDP) in Philippines in 2010?
Keep it short and to the point. -0.24. What is the difference between the Oil Rent (as % of GDP) of Israel in 2009 and the Oil Rent (as % of GDP) of Trinidad and Tobago in 2010?
Your response must be concise. -16.75. What is the difference between the Oil Rent (as % of GDP) in Philippines in 2009 and the Oil Rent (as % of GDP) in Trinidad and Tobago in 2010?
Keep it short and to the point. -16.49. What is the difference between the Oil Rent (as % of GDP) in Argentina in 2009 and the Oil Rent (as % of GDP) in Israel in 2011?
Your answer should be very brief. 2.89. What is the difference between the Oil Rent (as % of GDP) of Argentina in 2009 and the Oil Rent (as % of GDP) of Philippines in 2011?
Make the answer very short. 2.63. What is the difference between the Oil Rent (as % of GDP) in Argentina in 2009 and the Oil Rent (as % of GDP) in Trinidad and Tobago in 2011?
Your response must be concise. -15.61. What is the difference between the Oil Rent (as % of GDP) of Israel in 2009 and the Oil Rent (as % of GDP) of Philippines in 2011?
Ensure brevity in your answer.  -0.27. What is the difference between the Oil Rent (as % of GDP) of Israel in 2009 and the Oil Rent (as % of GDP) of Trinidad and Tobago in 2011?
Keep it short and to the point. -18.51. What is the difference between the Oil Rent (as % of GDP) in Philippines in 2009 and the Oil Rent (as % of GDP) in Trinidad and Tobago in 2011?
Offer a very short reply. -18.25. What is the difference between the Oil Rent (as % of GDP) in Argentina in 2010 and the Oil Rent (as % of GDP) in Israel in 2011?
Offer a terse response. 3.06. What is the difference between the Oil Rent (as % of GDP) of Argentina in 2010 and the Oil Rent (as % of GDP) of Philippines in 2011?
Your response must be concise. 2.79. What is the difference between the Oil Rent (as % of GDP) in Argentina in 2010 and the Oil Rent (as % of GDP) in Trinidad and Tobago in 2011?
Make the answer very short. -15.45. What is the difference between the Oil Rent (as % of GDP) of Israel in 2010 and the Oil Rent (as % of GDP) of Philippines in 2011?
Your answer should be compact. -0.27. What is the difference between the Oil Rent (as % of GDP) in Israel in 2010 and the Oil Rent (as % of GDP) in Trinidad and Tobago in 2011?
Your answer should be compact. -18.51. What is the difference between the Oil Rent (as % of GDP) in Philippines in 2010 and the Oil Rent (as % of GDP) in Trinidad and Tobago in 2011?
Offer a terse response. -18.26. What is the average Oil Rent (as % of GDP) of Argentina per year?
Keep it short and to the point. 4.1. What is the average Oil Rent (as % of GDP) in Israel per year?
Your response must be concise. 0. What is the average Oil Rent (as % of GDP) of Philippines per year?
Your answer should be compact. 0.26. What is the average Oil Rent (as % of GDP) of Trinidad and Tobago per year?
Your answer should be compact. 17.64. In the year 2004, what is the difference between the Oil Rent (as % of GDP) of Argentina and Oil Rent (as % of GDP) of Israel?
Keep it short and to the point. 4.34. In the year 2004, what is the difference between the Oil Rent (as % of GDP) of Argentina and Oil Rent (as % of GDP) of Philippines?
Give a very brief answer. 4.18. In the year 2004, what is the difference between the Oil Rent (as % of GDP) of Argentina and Oil Rent (as % of GDP) of Trinidad and Tobago?
Your answer should be compact. -10.38. In the year 2004, what is the difference between the Oil Rent (as % of GDP) of Israel and Oil Rent (as % of GDP) of Philippines?
Provide a short and direct response. -0.16. In the year 2004, what is the difference between the Oil Rent (as % of GDP) of Israel and Oil Rent (as % of GDP) of Trinidad and Tobago?
Your answer should be compact. -14.72. In the year 2004, what is the difference between the Oil Rent (as % of GDP) in Philippines and Oil Rent (as % of GDP) in Trinidad and Tobago?
Your answer should be very brief. -14.56. In the year 2005, what is the difference between the Oil Rent (as % of GDP) of Argentina and Oil Rent (as % of GDP) of Israel?
Make the answer very short. 4.99. In the year 2005, what is the difference between the Oil Rent (as % of GDP) in Argentina and Oil Rent (as % of GDP) in Philippines?
Your response must be concise. 4.72. In the year 2005, what is the difference between the Oil Rent (as % of GDP) of Argentina and Oil Rent (as % of GDP) of Trinidad and Tobago?
Your response must be concise. -14.03. In the year 2005, what is the difference between the Oil Rent (as % of GDP) in Israel and Oil Rent (as % of GDP) in Philippines?
Offer a terse response. -0.27. In the year 2005, what is the difference between the Oil Rent (as % of GDP) in Israel and Oil Rent (as % of GDP) in Trinidad and Tobago?
Make the answer very short. -19.03. In the year 2005, what is the difference between the Oil Rent (as % of GDP) of Philippines and Oil Rent (as % of GDP) of Trinidad and Tobago?
Your response must be concise. -18.76. In the year 2006, what is the difference between the Oil Rent (as % of GDP) of Argentina and Oil Rent (as % of GDP) of Israel?
Your answer should be compact. 5.12. In the year 2006, what is the difference between the Oil Rent (as % of GDP) in Argentina and Oil Rent (as % of GDP) in Philippines?
Ensure brevity in your answer.  4.86. In the year 2006, what is the difference between the Oil Rent (as % of GDP) of Argentina and Oil Rent (as % of GDP) of Trinidad and Tobago?
Give a very brief answer. -16.32. In the year 2006, what is the difference between the Oil Rent (as % of GDP) of Israel and Oil Rent (as % of GDP) of Philippines?
Your response must be concise. -0.25. In the year 2006, what is the difference between the Oil Rent (as % of GDP) of Israel and Oil Rent (as % of GDP) of Trinidad and Tobago?
Make the answer very short. -21.43. In the year 2006, what is the difference between the Oil Rent (as % of GDP) in Philippines and Oil Rent (as % of GDP) in Trinidad and Tobago?
Make the answer very short. -21.18. In the year 2007, what is the difference between the Oil Rent (as % of GDP) in Argentina and Oil Rent (as % of GDP) in Israel?
Your response must be concise. 4.37. In the year 2007, what is the difference between the Oil Rent (as % of GDP) of Argentina and Oil Rent (as % of GDP) of Philippines?
Give a very brief answer. 4.12. In the year 2007, what is the difference between the Oil Rent (as % of GDP) in Argentina and Oil Rent (as % of GDP) in Trinidad and Tobago?
Your response must be concise. -12.88. In the year 2007, what is the difference between the Oil Rent (as % of GDP) of Israel and Oil Rent (as % of GDP) of Philippines?
Your response must be concise. -0.25. In the year 2007, what is the difference between the Oil Rent (as % of GDP) in Israel and Oil Rent (as % of GDP) in Trinidad and Tobago?
Offer a very short reply. -17.25. In the year 2007, what is the difference between the Oil Rent (as % of GDP) of Philippines and Oil Rent (as % of GDP) of Trinidad and Tobago?
Give a very brief answer. -16.99. In the year 2008, what is the difference between the Oil Rent (as % of GDP) in Argentina and Oil Rent (as % of GDP) in Israel?
Make the answer very short. 4.8. In the year 2008, what is the difference between the Oil Rent (as % of GDP) in Argentina and Oil Rent (as % of GDP) in Philippines?
Provide a short and direct response. 4.47. In the year 2008, what is the difference between the Oil Rent (as % of GDP) of Argentina and Oil Rent (as % of GDP) of Trinidad and Tobago?
Make the answer very short. -14.58. In the year 2008, what is the difference between the Oil Rent (as % of GDP) of Israel and Oil Rent (as % of GDP) of Philippines?
Make the answer very short. -0.33. In the year 2008, what is the difference between the Oil Rent (as % of GDP) in Israel and Oil Rent (as % of GDP) in Trinidad and Tobago?
Provide a succinct answer. -19.38. In the year 2008, what is the difference between the Oil Rent (as % of GDP) in Philippines and Oil Rent (as % of GDP) in Trinidad and Tobago?
Your answer should be compact. -19.05. In the year 2009, what is the difference between the Oil Rent (as % of GDP) in Argentina and Oil Rent (as % of GDP) in Israel?
Provide a short and direct response. 2.89. In the year 2009, what is the difference between the Oil Rent (as % of GDP) of Argentina and Oil Rent (as % of GDP) of Philippines?
Provide a succinct answer. 2.64. In the year 2009, what is the difference between the Oil Rent (as % of GDP) in Argentina and Oil Rent (as % of GDP) in Trinidad and Tobago?
Make the answer very short. -11.14. In the year 2009, what is the difference between the Oil Rent (as % of GDP) in Israel and Oil Rent (as % of GDP) in Philippines?
Offer a terse response. -0.25. In the year 2009, what is the difference between the Oil Rent (as % of GDP) of Israel and Oil Rent (as % of GDP) of Trinidad and Tobago?
Make the answer very short. -14.03. In the year 2009, what is the difference between the Oil Rent (as % of GDP) of Philippines and Oil Rent (as % of GDP) of Trinidad and Tobago?
Your answer should be compact. -13.78. In the year 2010, what is the difference between the Oil Rent (as % of GDP) in Argentina and Oil Rent (as % of GDP) in Israel?
Provide a short and direct response. 3.06. In the year 2010, what is the difference between the Oil Rent (as % of GDP) in Argentina and Oil Rent (as % of GDP) in Philippines?
Offer a terse response. 2.82. In the year 2010, what is the difference between the Oil Rent (as % of GDP) in Argentina and Oil Rent (as % of GDP) in Trinidad and Tobago?
Offer a terse response. -13.69. In the year 2010, what is the difference between the Oil Rent (as % of GDP) in Israel and Oil Rent (as % of GDP) in Philippines?
Your answer should be compact. -0.24. In the year 2010, what is the difference between the Oil Rent (as % of GDP) of Israel and Oil Rent (as % of GDP) of Trinidad and Tobago?
Ensure brevity in your answer.  -16.75. In the year 2010, what is the difference between the Oil Rent (as % of GDP) of Philippines and Oil Rent (as % of GDP) of Trinidad and Tobago?
Offer a terse response. -16.5. In the year 2011, what is the difference between the Oil Rent (as % of GDP) in Argentina and Oil Rent (as % of GDP) in Israel?
Your answer should be very brief. 3.24. In the year 2011, what is the difference between the Oil Rent (as % of GDP) in Argentina and Oil Rent (as % of GDP) in Philippines?
Your answer should be compact. 2.97. In the year 2011, what is the difference between the Oil Rent (as % of GDP) in Argentina and Oil Rent (as % of GDP) in Trinidad and Tobago?
Make the answer very short. -15.27. In the year 2011, what is the difference between the Oil Rent (as % of GDP) in Israel and Oil Rent (as % of GDP) in Philippines?
Give a very brief answer. -0.26. In the year 2011, what is the difference between the Oil Rent (as % of GDP) in Israel and Oil Rent (as % of GDP) in Trinidad and Tobago?
Provide a succinct answer. -18.5. In the year 2011, what is the difference between the Oil Rent (as % of GDP) of Philippines and Oil Rent (as % of GDP) of Trinidad and Tobago?
Offer a terse response. -18.24. What is the ratio of the Oil Rent (as % of GDP) in Argentina in 2004 to that in 2005?
Make the answer very short. 0.87. What is the ratio of the Oil Rent (as % of GDP) in Israel in 2004 to that in 2005?
Provide a succinct answer. 0.54. What is the ratio of the Oil Rent (as % of GDP) of Philippines in 2004 to that in 2005?
Your answer should be very brief. 0.61. What is the ratio of the Oil Rent (as % of GDP) in Trinidad and Tobago in 2004 to that in 2005?
Make the answer very short. 0.77. What is the ratio of the Oil Rent (as % of GDP) in Argentina in 2004 to that in 2006?
Your answer should be compact. 0.85. What is the ratio of the Oil Rent (as % of GDP) of Israel in 2004 to that in 2006?
Your answer should be compact. 0.48. What is the ratio of the Oil Rent (as % of GDP) of Philippines in 2004 to that in 2006?
Keep it short and to the point. 0.65. What is the ratio of the Oil Rent (as % of GDP) of Trinidad and Tobago in 2004 to that in 2006?
Ensure brevity in your answer.  0.69. What is the ratio of the Oil Rent (as % of GDP) in Argentina in 2004 to that in 2007?
Keep it short and to the point. 0.99. What is the ratio of the Oil Rent (as % of GDP) of Israel in 2004 to that in 2007?
Offer a very short reply. 0.51. What is the ratio of the Oil Rent (as % of GDP) of Philippines in 2004 to that in 2007?
Your response must be concise. 0.65. What is the ratio of the Oil Rent (as % of GDP) of Trinidad and Tobago in 2004 to that in 2007?
Your answer should be compact. 0.85. What is the ratio of the Oil Rent (as % of GDP) of Argentina in 2004 to that in 2008?
Your answer should be compact. 0.9. What is the ratio of the Oil Rent (as % of GDP) of Israel in 2004 to that in 2008?
Offer a very short reply. 0.45. What is the ratio of the Oil Rent (as % of GDP) in Philippines in 2004 to that in 2008?
Provide a short and direct response. 0.5. What is the ratio of the Oil Rent (as % of GDP) in Trinidad and Tobago in 2004 to that in 2008?
Your answer should be compact. 0.76. What is the ratio of the Oil Rent (as % of GDP) in Argentina in 2004 to that in 2009?
Provide a short and direct response. 1.5. What is the ratio of the Oil Rent (as % of GDP) in Israel in 2004 to that in 2009?
Offer a very short reply. 0.75. What is the ratio of the Oil Rent (as % of GDP) in Philippines in 2004 to that in 2009?
Offer a very short reply. 0.65. What is the ratio of the Oil Rent (as % of GDP) in Trinidad and Tobago in 2004 to that in 2009?
Your response must be concise. 1.05. What is the ratio of the Oil Rent (as % of GDP) in Argentina in 2004 to that in 2010?
Ensure brevity in your answer.  1.42. What is the ratio of the Oil Rent (as % of GDP) in Israel in 2004 to that in 2010?
Make the answer very short. 0.64. What is the ratio of the Oil Rent (as % of GDP) of Philippines in 2004 to that in 2010?
Your answer should be compact. 0.67. What is the ratio of the Oil Rent (as % of GDP) in Trinidad and Tobago in 2004 to that in 2010?
Give a very brief answer. 0.88. What is the ratio of the Oil Rent (as % of GDP) in Argentina in 2004 to that in 2011?
Your response must be concise. 1.34. What is the ratio of the Oil Rent (as % of GDP) of Israel in 2004 to that in 2011?
Keep it short and to the point. 0.14. What is the ratio of the Oil Rent (as % of GDP) in Philippines in 2004 to that in 2011?
Give a very brief answer. 0.61. What is the ratio of the Oil Rent (as % of GDP) in Trinidad and Tobago in 2004 to that in 2011?
Make the answer very short. 0.8. What is the ratio of the Oil Rent (as % of GDP) of Argentina in 2005 to that in 2006?
Your answer should be very brief. 0.98. What is the ratio of the Oil Rent (as % of GDP) in Israel in 2005 to that in 2006?
Your answer should be very brief. 0.89. What is the ratio of the Oil Rent (as % of GDP) of Philippines in 2005 to that in 2006?
Your response must be concise. 1.07. What is the ratio of the Oil Rent (as % of GDP) in Trinidad and Tobago in 2005 to that in 2006?
Provide a short and direct response. 0.89. What is the ratio of the Oil Rent (as % of GDP) in Argentina in 2005 to that in 2007?
Keep it short and to the point. 1.14. What is the ratio of the Oil Rent (as % of GDP) of Israel in 2005 to that in 2007?
Offer a very short reply. 0.94. What is the ratio of the Oil Rent (as % of GDP) in Philippines in 2005 to that in 2007?
Make the answer very short. 1.06. What is the ratio of the Oil Rent (as % of GDP) in Trinidad and Tobago in 2005 to that in 2007?
Provide a short and direct response. 1.1. What is the ratio of the Oil Rent (as % of GDP) in Argentina in 2005 to that in 2008?
Keep it short and to the point. 1.04. What is the ratio of the Oil Rent (as % of GDP) of Israel in 2005 to that in 2008?
Provide a short and direct response. 0.82. What is the ratio of the Oil Rent (as % of GDP) of Philippines in 2005 to that in 2008?
Offer a terse response. 0.82. What is the ratio of the Oil Rent (as % of GDP) of Trinidad and Tobago in 2005 to that in 2008?
Your answer should be very brief. 0.98. What is the ratio of the Oil Rent (as % of GDP) of Argentina in 2005 to that in 2009?
Provide a short and direct response. 1.73. What is the ratio of the Oil Rent (as % of GDP) of Israel in 2005 to that in 2009?
Ensure brevity in your answer.  1.37. What is the ratio of the Oil Rent (as % of GDP) of Philippines in 2005 to that in 2009?
Your answer should be compact. 1.06. What is the ratio of the Oil Rent (as % of GDP) in Trinidad and Tobago in 2005 to that in 2009?
Give a very brief answer. 1.36. What is the ratio of the Oil Rent (as % of GDP) in Argentina in 2005 to that in 2010?
Provide a short and direct response. 1.63. What is the ratio of the Oil Rent (as % of GDP) of Israel in 2005 to that in 2010?
Your answer should be very brief. 1.18. What is the ratio of the Oil Rent (as % of GDP) in Philippines in 2005 to that in 2010?
Your answer should be very brief. 1.1. What is the ratio of the Oil Rent (as % of GDP) in Trinidad and Tobago in 2005 to that in 2010?
Offer a terse response. 1.14. What is the ratio of the Oil Rent (as % of GDP) in Argentina in 2005 to that in 2011?
Ensure brevity in your answer.  1.54. What is the ratio of the Oil Rent (as % of GDP) in Israel in 2005 to that in 2011?
Your answer should be compact. 0.25. What is the ratio of the Oil Rent (as % of GDP) in Philippines in 2005 to that in 2011?
Offer a terse response. 1.01. What is the ratio of the Oil Rent (as % of GDP) of Trinidad and Tobago in 2005 to that in 2011?
Your answer should be very brief. 1.03. What is the ratio of the Oil Rent (as % of GDP) of Argentina in 2006 to that in 2007?
Give a very brief answer. 1.17. What is the ratio of the Oil Rent (as % of GDP) of Israel in 2006 to that in 2007?
Offer a terse response. 1.05. What is the ratio of the Oil Rent (as % of GDP) of Philippines in 2006 to that in 2007?
Offer a terse response. 0.99. What is the ratio of the Oil Rent (as % of GDP) of Trinidad and Tobago in 2006 to that in 2007?
Offer a very short reply. 1.24. What is the ratio of the Oil Rent (as % of GDP) in Argentina in 2006 to that in 2008?
Provide a short and direct response. 1.07. What is the ratio of the Oil Rent (as % of GDP) in Israel in 2006 to that in 2008?
Offer a terse response. 0.93. What is the ratio of the Oil Rent (as % of GDP) in Philippines in 2006 to that in 2008?
Provide a succinct answer. 0.77. What is the ratio of the Oil Rent (as % of GDP) in Trinidad and Tobago in 2006 to that in 2008?
Your answer should be compact. 1.11. What is the ratio of the Oil Rent (as % of GDP) of Argentina in 2006 to that in 2009?
Keep it short and to the point. 1.77. What is the ratio of the Oil Rent (as % of GDP) in Israel in 2006 to that in 2009?
Make the answer very short. 1.54. What is the ratio of the Oil Rent (as % of GDP) in Trinidad and Tobago in 2006 to that in 2009?
Offer a terse response. 1.53. What is the ratio of the Oil Rent (as % of GDP) in Argentina in 2006 to that in 2010?
Ensure brevity in your answer.  1.67. What is the ratio of the Oil Rent (as % of GDP) of Israel in 2006 to that in 2010?
Make the answer very short. 1.32. What is the ratio of the Oil Rent (as % of GDP) of Trinidad and Tobago in 2006 to that in 2010?
Provide a succinct answer. 1.28. What is the ratio of the Oil Rent (as % of GDP) in Argentina in 2006 to that in 2011?
Make the answer very short. 1.58. What is the ratio of the Oil Rent (as % of GDP) in Israel in 2006 to that in 2011?
Give a very brief answer. 0.28. What is the ratio of the Oil Rent (as % of GDP) in Philippines in 2006 to that in 2011?
Keep it short and to the point. 0.94. What is the ratio of the Oil Rent (as % of GDP) of Trinidad and Tobago in 2006 to that in 2011?
Make the answer very short. 1.16. What is the ratio of the Oil Rent (as % of GDP) in Argentina in 2007 to that in 2008?
Give a very brief answer. 0.91. What is the ratio of the Oil Rent (as % of GDP) in Israel in 2007 to that in 2008?
Provide a short and direct response. 0.88. What is the ratio of the Oil Rent (as % of GDP) of Philippines in 2007 to that in 2008?
Keep it short and to the point. 0.77. What is the ratio of the Oil Rent (as % of GDP) in Trinidad and Tobago in 2007 to that in 2008?
Offer a terse response. 0.89. What is the ratio of the Oil Rent (as % of GDP) in Argentina in 2007 to that in 2009?
Ensure brevity in your answer.  1.51. What is the ratio of the Oil Rent (as % of GDP) in Israel in 2007 to that in 2009?
Keep it short and to the point. 1.46. What is the ratio of the Oil Rent (as % of GDP) of Philippines in 2007 to that in 2009?
Provide a short and direct response. 1. What is the ratio of the Oil Rent (as % of GDP) in Trinidad and Tobago in 2007 to that in 2009?
Provide a short and direct response. 1.23. What is the ratio of the Oil Rent (as % of GDP) in Argentina in 2007 to that in 2010?
Your answer should be compact. 1.43. What is the ratio of the Oil Rent (as % of GDP) in Israel in 2007 to that in 2010?
Provide a succinct answer. 1.25. What is the ratio of the Oil Rent (as % of GDP) of Philippines in 2007 to that in 2010?
Your answer should be very brief. 1.04. What is the ratio of the Oil Rent (as % of GDP) of Trinidad and Tobago in 2007 to that in 2010?
Offer a terse response. 1.03. What is the ratio of the Oil Rent (as % of GDP) in Argentina in 2007 to that in 2011?
Offer a very short reply. 1.35. What is the ratio of the Oil Rent (as % of GDP) of Israel in 2007 to that in 2011?
Your response must be concise. 0.27. What is the ratio of the Oil Rent (as % of GDP) in Philippines in 2007 to that in 2011?
Give a very brief answer. 0.95. What is the ratio of the Oil Rent (as % of GDP) of Trinidad and Tobago in 2007 to that in 2011?
Make the answer very short. 0.93. What is the ratio of the Oil Rent (as % of GDP) of Argentina in 2008 to that in 2009?
Keep it short and to the point. 1.66. What is the ratio of the Oil Rent (as % of GDP) of Israel in 2008 to that in 2009?
Provide a short and direct response. 1.66. What is the ratio of the Oil Rent (as % of GDP) of Philippines in 2008 to that in 2009?
Your answer should be very brief. 1.3. What is the ratio of the Oil Rent (as % of GDP) of Trinidad and Tobago in 2008 to that in 2009?
Offer a terse response. 1.38. What is the ratio of the Oil Rent (as % of GDP) of Argentina in 2008 to that in 2010?
Keep it short and to the point. 1.57. What is the ratio of the Oil Rent (as % of GDP) in Israel in 2008 to that in 2010?
Provide a short and direct response. 1.43. What is the ratio of the Oil Rent (as % of GDP) of Philippines in 2008 to that in 2010?
Provide a succinct answer. 1.34. What is the ratio of the Oil Rent (as % of GDP) of Trinidad and Tobago in 2008 to that in 2010?
Your response must be concise. 1.16. What is the ratio of the Oil Rent (as % of GDP) in Argentina in 2008 to that in 2011?
Offer a very short reply. 1.48. What is the ratio of the Oil Rent (as % of GDP) in Israel in 2008 to that in 2011?
Your answer should be very brief. 0.3. What is the ratio of the Oil Rent (as % of GDP) of Philippines in 2008 to that in 2011?
Your response must be concise. 1.23. What is the ratio of the Oil Rent (as % of GDP) in Trinidad and Tobago in 2008 to that in 2011?
Offer a very short reply. 1.05. What is the ratio of the Oil Rent (as % of GDP) in Argentina in 2009 to that in 2010?
Ensure brevity in your answer.  0.95. What is the ratio of the Oil Rent (as % of GDP) in Israel in 2009 to that in 2010?
Provide a short and direct response. 0.86. What is the ratio of the Oil Rent (as % of GDP) in Philippines in 2009 to that in 2010?
Your response must be concise. 1.04. What is the ratio of the Oil Rent (as % of GDP) of Trinidad and Tobago in 2009 to that in 2010?
Provide a short and direct response. 0.84. What is the ratio of the Oil Rent (as % of GDP) in Argentina in 2009 to that in 2011?
Ensure brevity in your answer.  0.89. What is the ratio of the Oil Rent (as % of GDP) in Israel in 2009 to that in 2011?
Provide a succinct answer. 0.18. What is the ratio of the Oil Rent (as % of GDP) in Philippines in 2009 to that in 2011?
Your answer should be very brief. 0.95. What is the ratio of the Oil Rent (as % of GDP) in Trinidad and Tobago in 2009 to that in 2011?
Provide a short and direct response. 0.76. What is the ratio of the Oil Rent (as % of GDP) of Argentina in 2010 to that in 2011?
Offer a terse response. 0.94. What is the ratio of the Oil Rent (as % of GDP) in Israel in 2010 to that in 2011?
Offer a very short reply. 0.21. What is the ratio of the Oil Rent (as % of GDP) in Philippines in 2010 to that in 2011?
Provide a succinct answer. 0.91. What is the ratio of the Oil Rent (as % of GDP) of Trinidad and Tobago in 2010 to that in 2011?
Provide a short and direct response. 0.9. What is the difference between the highest and the second highest Oil Rent (as % of GDP) of Argentina?
Make the answer very short. 0.12. What is the difference between the highest and the second highest Oil Rent (as % of GDP) of Israel?
Provide a succinct answer. 0. What is the difference between the highest and the second highest Oil Rent (as % of GDP) of Philippines?
Your answer should be very brief. 0.06. What is the difference between the highest and the second highest Oil Rent (as % of GDP) of Trinidad and Tobago?
Offer a very short reply. 2.06. What is the difference between the highest and the lowest Oil Rent (as % of GDP) of Argentina?
Offer a terse response. 2.22. What is the difference between the highest and the lowest Oil Rent (as % of GDP) of Israel?
Ensure brevity in your answer.  0. What is the difference between the highest and the lowest Oil Rent (as % of GDP) of Philippines?
Make the answer very short. 0.17. What is the difference between the highest and the lowest Oil Rent (as % of GDP) in Trinidad and Tobago?
Provide a succinct answer. 7.4. 